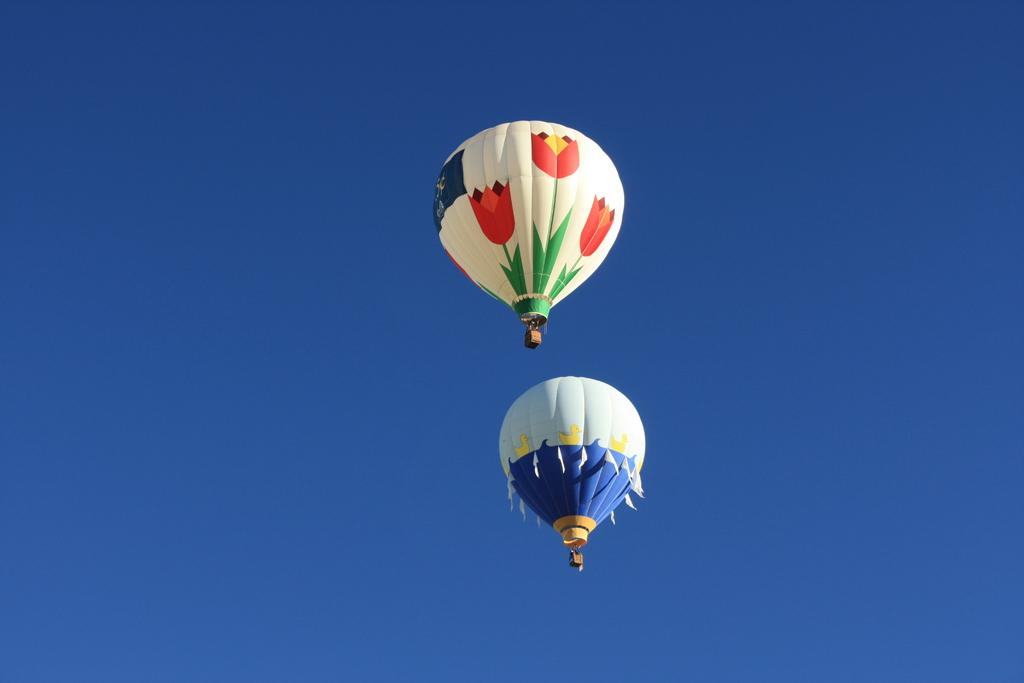What is the main subject of the picture? The main subject of the picture is two hot air balloons. What colors are the hot air balloons? The hot air balloons are in blue, white, red, and green colors. What can be seen in the background of the picture? The sky is visible in the background of the picture. What is the color of the sky in the picture? The sky is blue in color. How many rocks can be seen in the picture? There are no rocks present in the picture; it features two hot air balloons and a blue sky. What type of calculator is being used by the hot air balloon pilot? There is no calculator visible in the picture, as it focuses on the hot air balloons and the sky. 